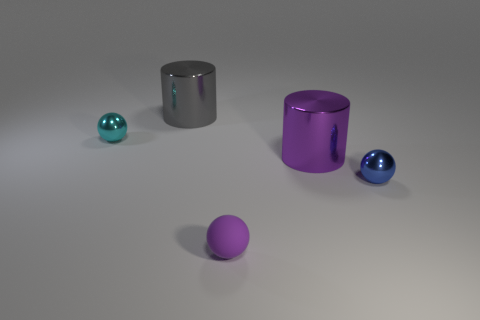Do the big thing that is behind the large purple shiny cylinder and the rubber thing have the same shape?
Your answer should be very brief. No. Are there any tiny cyan metal things in front of the large purple shiny cylinder?
Keep it short and to the point. No. What number of large things are green rubber blocks or metallic cylinders?
Your answer should be compact. 2. Are the tiny cyan object and the gray thing made of the same material?
Give a very brief answer. Yes. What is the size of the cylinder that is the same color as the matte thing?
Keep it short and to the point. Large. Are there any rubber things of the same color as the small matte ball?
Provide a short and direct response. No. What is the size of the purple object that is the same material as the gray cylinder?
Offer a very short reply. Large. There is a small metal object that is to the left of the purple object that is left of the purple metallic cylinder that is behind the purple sphere; what shape is it?
Your answer should be very brief. Sphere. What size is the other cyan thing that is the same shape as the rubber object?
Your response must be concise. Small. There is a metallic object that is in front of the big gray object and behind the big purple object; how big is it?
Provide a succinct answer. Small. 